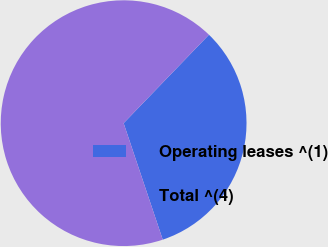<chart> <loc_0><loc_0><loc_500><loc_500><pie_chart><fcel>Operating leases ^(1)<fcel>Total ^(4)<nl><fcel>32.63%<fcel>67.37%<nl></chart> 